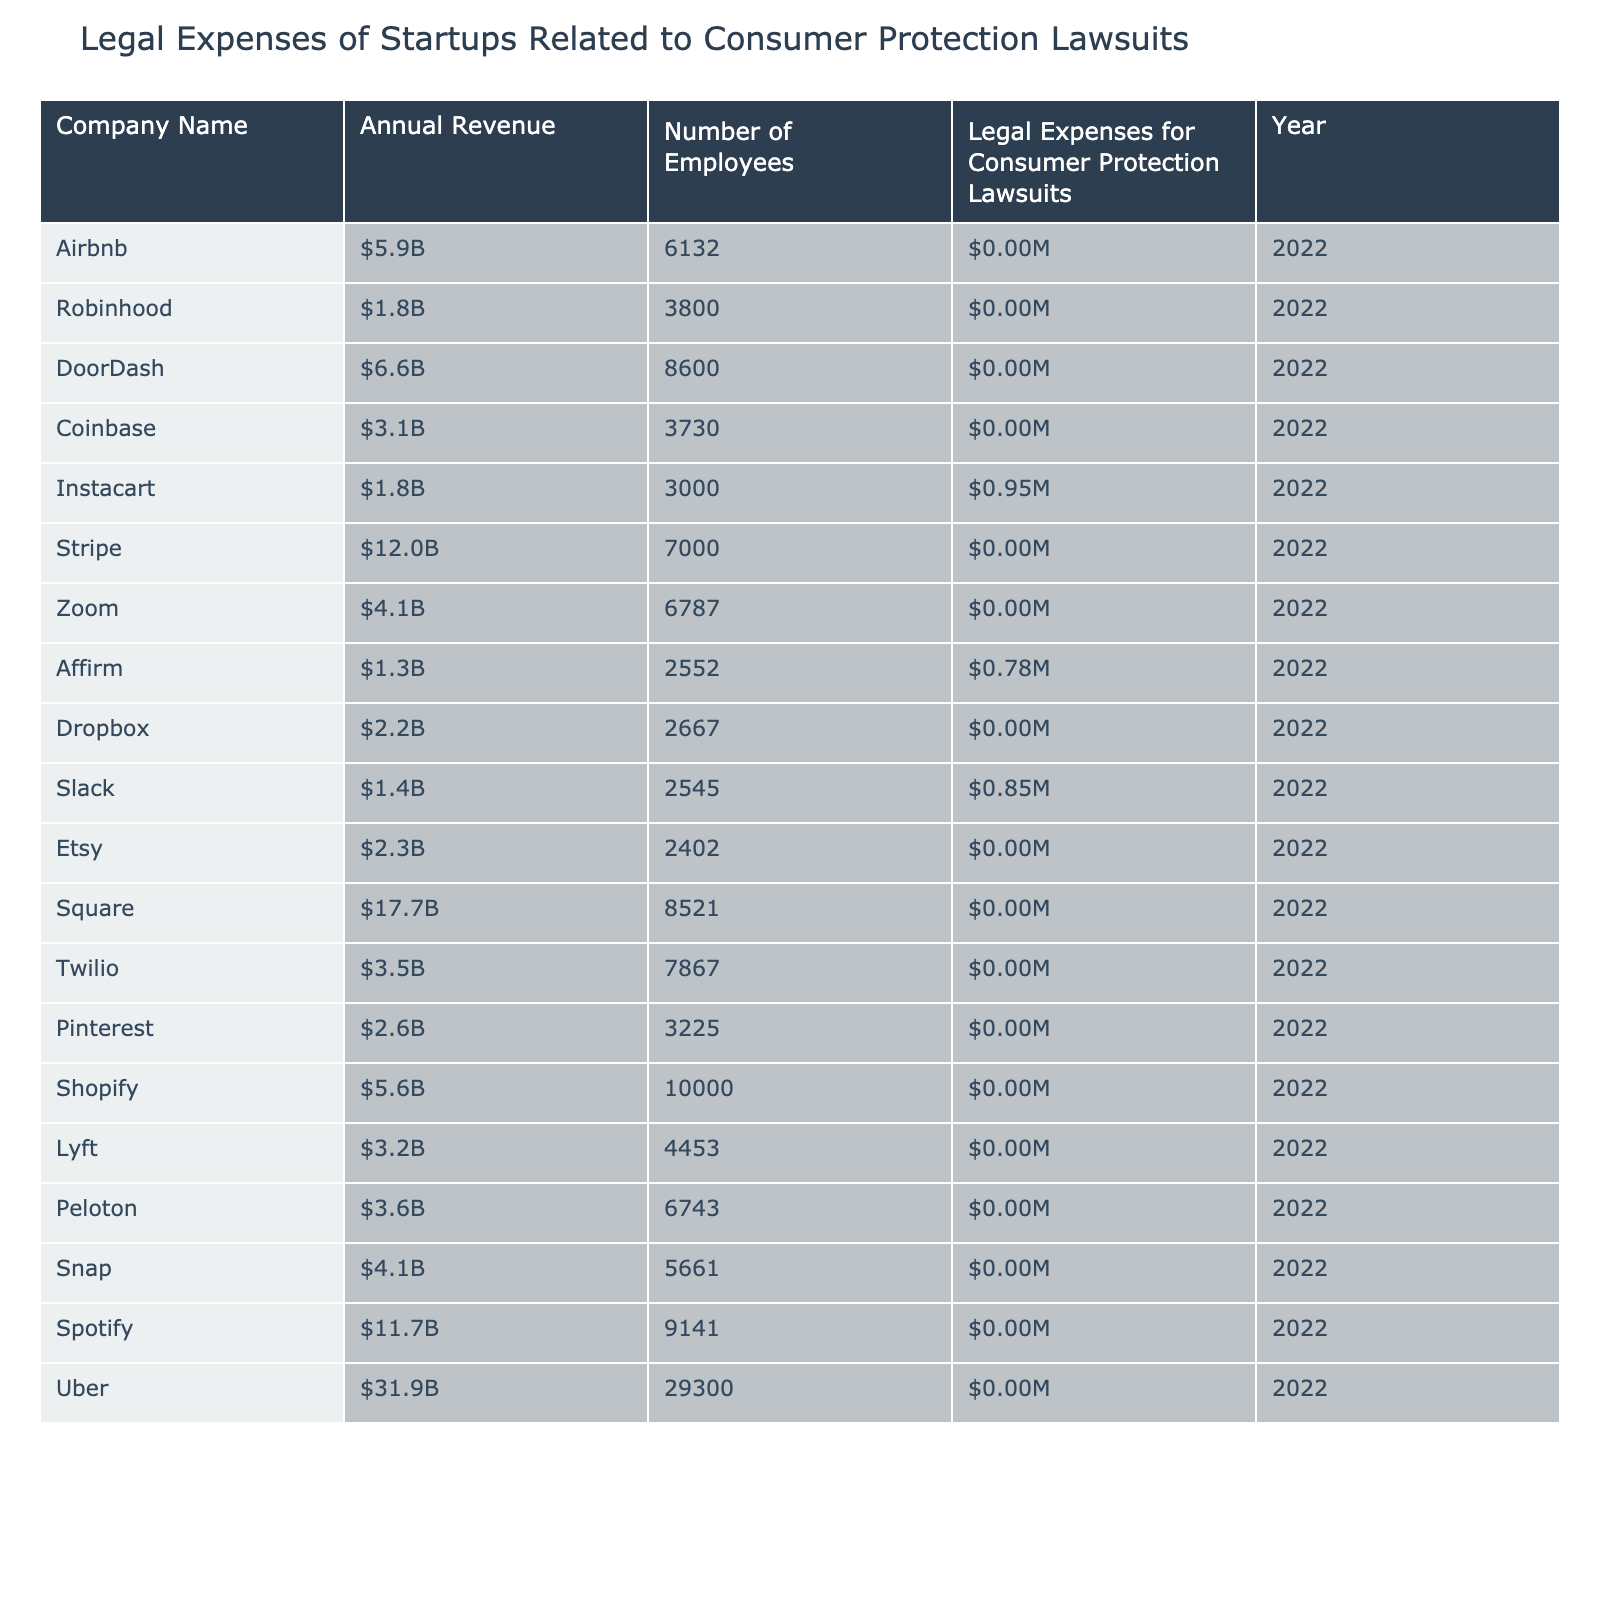What is the legal expense of Airbnb for consumer protection lawsuits? The table shows that Airbnb's legal expenses for consumer protection lawsuits are $2.1 million in the year 2022.
Answer: $2.1 million What is the total legal expense for consumer protection lawsuits by all companies listed? To find the total legal expenses, I sum the legal expenses for each company: $2.1M + $4.5M + $1.8M + $3.2M + $0.95M + $2.7M + $1.5M + $0.78M + $1.2M + $0.85M + $1.1M + $3.5M + $1.9M + $1.3M + $2.4M + $1.7M + $2.2M + $2.0M + $2.8M + $5.5M = $38.75M.
Answer: $38.75 million Which company has the highest legal expenses, and what is that amount? By comparing the legal expenses for all companies, Uber has the highest expense at $5.5 million.
Answer: Uber, $5.5 million Is Instacart's legal expense higher than that of DoorDash? Instacart has legal expenses of $950,000, while DoorDash has expenses of $1.8 million. Since $950,000 is less than $1.8 million, the answer is no.
Answer: No What is the average legal expense for consumer protection lawsuits across all companies? To find the average, I sum the legal expenses which total $38.75 million and divide by the total number of companies, which is 20. So, average = $38.75M / 20 = $1.9375M.
Answer: $1.94 million How does the legal expense of Spotify compare to that of Zoom? Spotify's legal expenses are $2.8 million and Zoom's expenses are $1.5 million. Since $2.8 million is greater than $1.5 million, Spotify has higher expenses than Zoom.
Answer: Spotify has higher expenses What percentage of the total legal expenses do Uber's expenses represent? Uber's expenses are $5.5 million, and the total expenses are $38.75 million. To find the percentage: ($5.5M / $38.75M) * 100 = 14.19%, so Uber's expenses represent approximately 14.19% of the total.
Answer: 14.19% Which company has the least legal expenses, and how much is that? By looking at the legal expenses, Affirm has the least expenses at $780,000 in 2022.
Answer: Affirm, $780,000 Is there any startup with legal expenses between $1 million and $2 million? By checking the expenses, companies like Dropbox ($1.2 million), Etsy ($1.1 million), and Snap ($2 million) fall into this range. Therefore, yes, there are companies with legal expenses in this range.
Answer: Yes, multiple companies What is the relationship between annual revenue and legal expenses for startups in this table? Examining the data, while companies with higher revenues often have higher legal expenses, the relationship is not strictly linear. For example, despite having higher revenues than some other companies, Instacart has lower legal expenses.
Answer: Not a strict linear relationship 